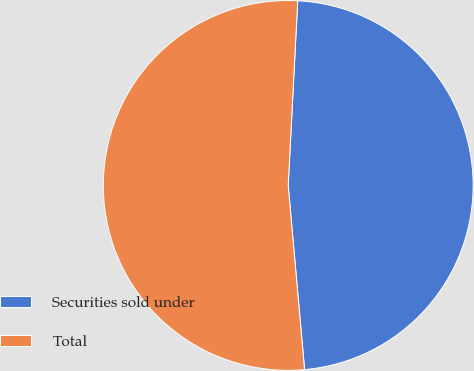<chart> <loc_0><loc_0><loc_500><loc_500><pie_chart><fcel>Securities sold under<fcel>Total<nl><fcel>47.77%<fcel>52.23%<nl></chart> 